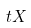<formula> <loc_0><loc_0><loc_500><loc_500>t X</formula> 